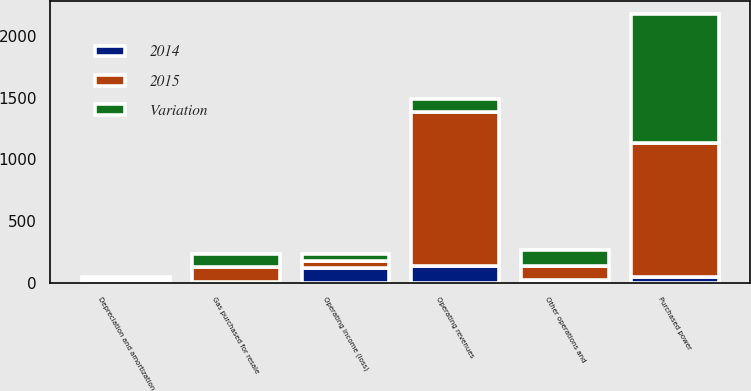Convert chart. <chart><loc_0><loc_0><loc_500><loc_500><stacked_bar_chart><ecel><fcel>Operating revenues<fcel>Purchased power<fcel>Gas purchased for resale<fcel>Other operations and<fcel>Depreciation and amortization<fcel>Operating income (loss)<nl><fcel>Variation<fcel>106<fcel>1044<fcel>106<fcel>134<fcel>22<fcel>58<nl><fcel>2015<fcel>1244<fcel>1088<fcel>115<fcel>108<fcel>19<fcel>60<nl><fcel>2014<fcel>139<fcel>44<fcel>9<fcel>26<fcel>3<fcel>118<nl></chart> 